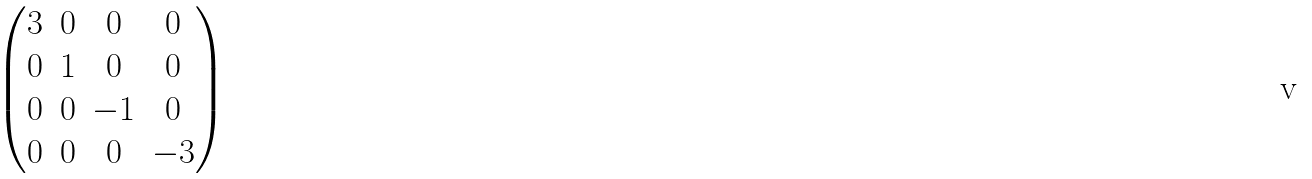<formula> <loc_0><loc_0><loc_500><loc_500>\begin{pmatrix} 3 & 0 & 0 & 0 \\ 0 & 1 & 0 & 0 \\ 0 & 0 & - 1 & 0 \\ 0 & 0 & 0 & - 3 \end{pmatrix}</formula> 